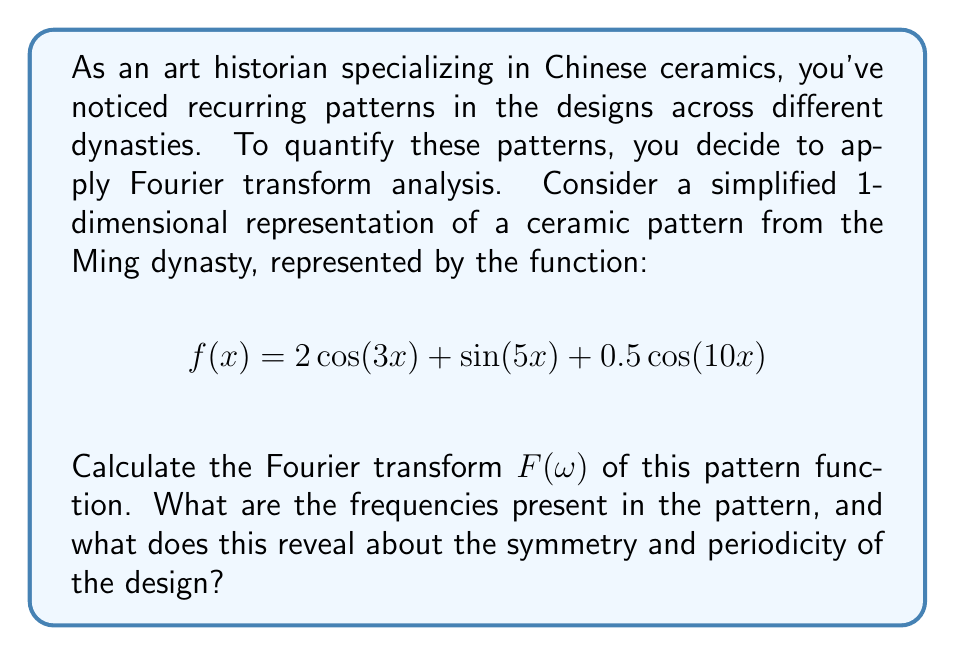Give your solution to this math problem. To solve this problem, we'll follow these steps:

1) Recall the Fourier transform formula for a continuous function:

   $$F(\omega) = \int_{-\infty}^{\infty} f(x) e^{-i\omega x} dx$$

2) For our function $f(x) = 2\cos(3x) + \sin(5x) + 0.5\cos(10x)$, we need to apply the Fourier transform to each term separately and then sum the results due to the linearity property of Fourier transforms.

3) We'll use the following Fourier transform pairs:
   
   $\cos(ax) \Leftrightarrow \pi[\delta(\omega+a) + \delta(\omega-a)]$
   
   $\sin(ax) \Leftrightarrow \frac{i\pi}{2}[\delta(\omega+a) - \delta(\omega-a)]$

   where $\delta$ is the Dirac delta function.

4) Applying these to our function:

   For $2\cos(3x)$:
   $2\pi[\delta(\omega+3) + \delta(\omega-3)]$

   For $\sin(5x)$:
   $\frac{i\pi}{2}[\delta(\omega+5) - \delta(\omega-5)]$

   For $0.5\cos(10x)$:
   $0.5\pi[\delta(\omega+10) + \delta(\omega-10)]$

5) Summing these results:

   $$F(\omega) = 2\pi[\delta(\omega+3) + \delta(\omega-3)] + \frac{i\pi}{2}[\delta(\omega+5) - \delta(\omega-5)] + 0.5\pi[\delta(\omega+10) + \delta(\omega-10)]$$

6) The frequencies present in the pattern are 3, 5, and 10 (and their negatives due to the symmetry of the Fourier transform for real functions).

7) Interpretation: The presence of these specific frequencies reveals that the pattern has components repeating at different rates. The 3 and 10 frequency components represent symmetric (cosine) patterns, while the 5 frequency component represents an asymmetric (sine) pattern. The coefficients (2, 1, and 0.5) indicate the relative strengths of these patterns.

This analysis reveals that the Ming dynasty ceramic design has multiple layers of symmetry and periodicity, with the strongest component (coefficient 2) at frequency 3, a medium component (coefficient 1) at frequency 5, and a weaker component (coefficient 0.5) at frequency 10. This suggests a complex, multi-layered design with both symmetric and asymmetric elements.
Answer: The Fourier transform of the pattern function is:

$$F(\omega) = 2\pi[\delta(\omega+3) + \delta(\omega-3)] + \frac{i\pi}{2}[\delta(\omega+5) - \delta(\omega-5)] + 0.5\pi[\delta(\omega+10) + \delta(\omega-10)]$$

The frequencies present are 3, 5, and 10 (and their negatives). This reveals a multi-layered design with varying levels of symmetry and periodicity, combining both symmetric (frequencies 3 and 10) and asymmetric (frequency 5) elements. 